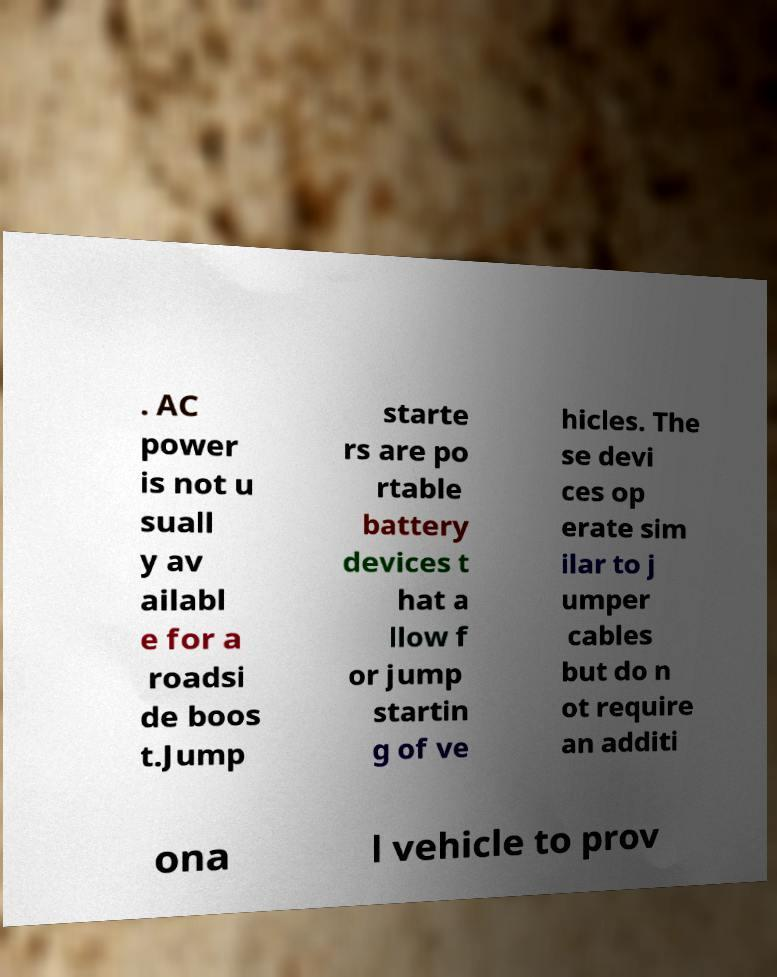What messages or text are displayed in this image? I need them in a readable, typed format. . AC power is not u suall y av ailabl e for a roadsi de boos t.Jump starte rs are po rtable battery devices t hat a llow f or jump startin g of ve hicles. The se devi ces op erate sim ilar to j umper cables but do n ot require an additi ona l vehicle to prov 